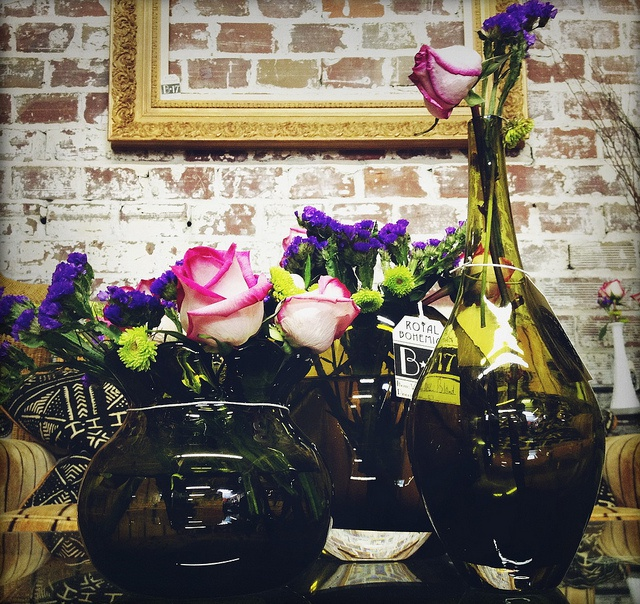Describe the objects in this image and their specific colors. I can see vase in gray, black, olive, and khaki tones, vase in gray, black, darkgreen, and white tones, couch in gray, black, and olive tones, vase in gray, black, ivory, maroon, and beige tones, and couch in gray, black, olive, and maroon tones in this image. 